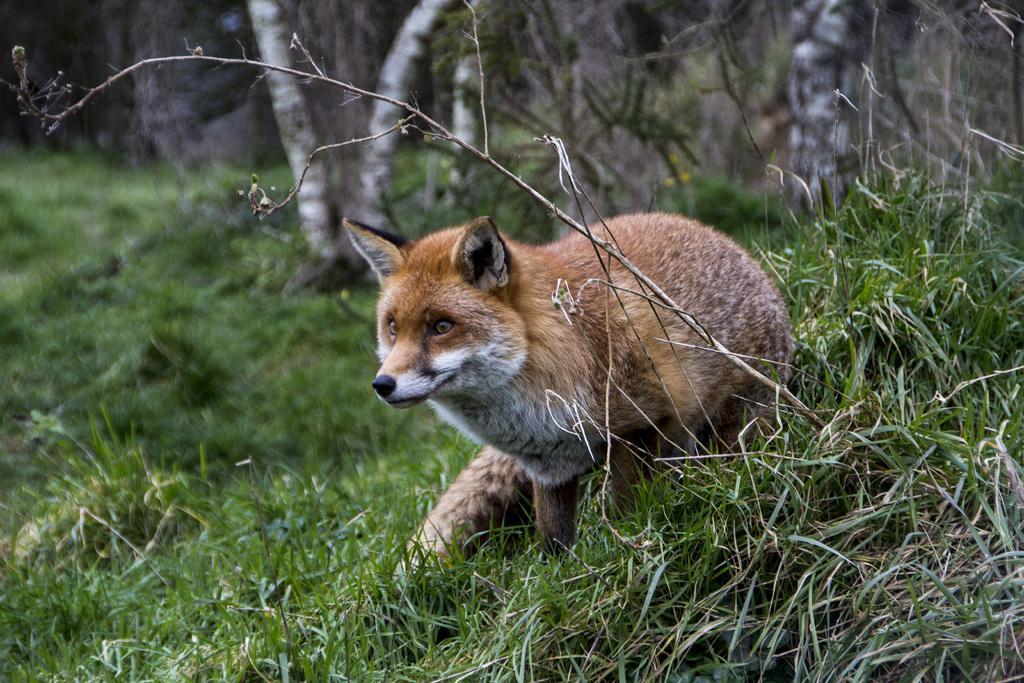In one or two sentences, can you explain what this image depicts? In this image I see a fox which is of white and cream in color and I see the green grass and it is blurred in the background. 